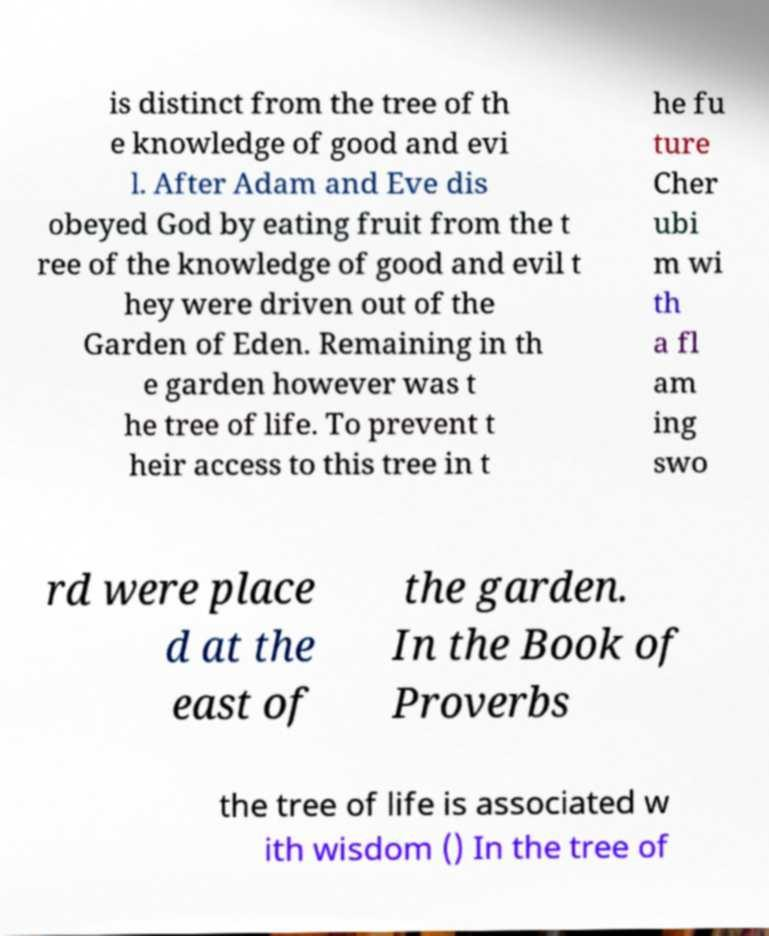Please identify and transcribe the text found in this image. is distinct from the tree of th e knowledge of good and evi l. After Adam and Eve dis obeyed God by eating fruit from the t ree of the knowledge of good and evil t hey were driven out of the Garden of Eden. Remaining in th e garden however was t he tree of life. To prevent t heir access to this tree in t he fu ture Cher ubi m wi th a fl am ing swo rd were place d at the east of the garden. In the Book of Proverbs the tree of life is associated w ith wisdom () In the tree of 